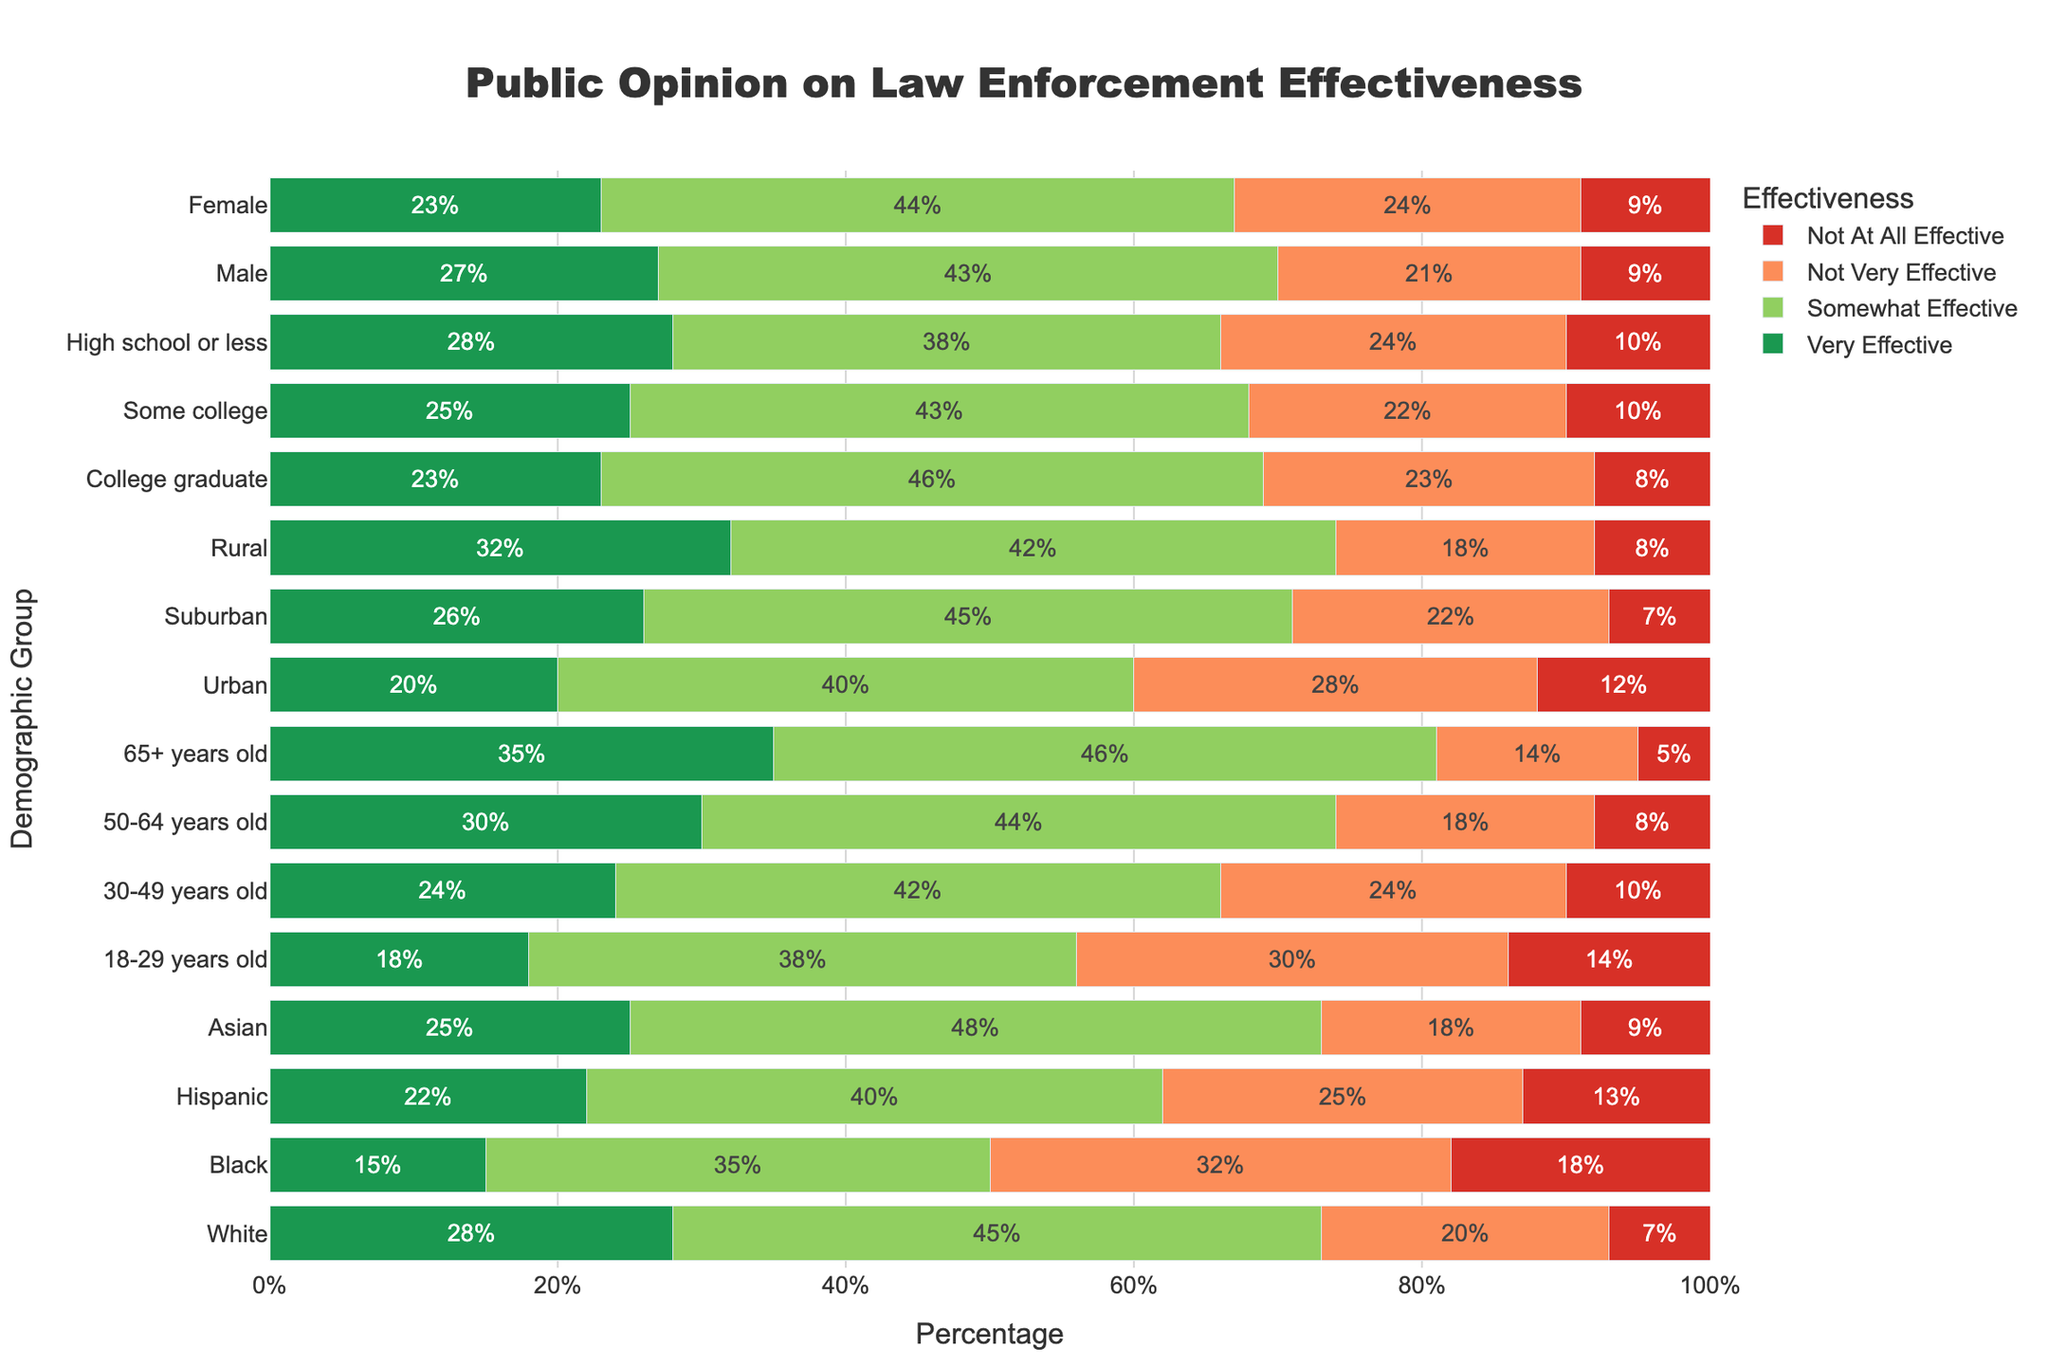What demographic group believes law enforcement is "Very Effective" the most? Looking at the figure, the bar for "Very Effective" is longest for the group "65+ years old" indicating the highest percentage, which is 35%.
Answer: 65+ years old Which group has the highest percentage of people thinking law enforcement is "Not At All Effective"? The longest red bar (representing "Not At All Effective") is for the "Black" demographic, showing 18%.
Answer: Black How does the opinion of "Very Effective" on law enforcement differ between "Male" and "Female"? The "Very Effective" bar for "Male" is at 27%, whereas for "Female" it is at 23%. So the difference is 27% - 23% = 4%.
Answer: 4% Which age group has the greatest percentage of individuals who believe law enforcement is "Not Very Effective"? The longest orange bar (representing "Not Very Effective") among age groups is for "18-29 years old," showing 30%.
Answer: 18-29 years old Compare the percentage of people in "Urban" areas who believe law enforcement is "Somewhat Effective" to those in "Rural" areas. The green bar for "Somewhat Effective" is 40% for "Urban" and 42% for "Rural". Hence, 42% is higher than 40%.
Answer: Rural > Urban What is the combined percentage of "Very Effective" and "Somewhat Effective" for the White demographic? For the White demographic, "Very Effective" is 28% and "Somewhat Effective" is 45%. Combining them leads to 28% + 45% = 73%.
Answer: 73% Which demographic group has the smallest proportion of individuals who think law enforcement is "Not Very Effective"? The shortest orange bar (representing "Not Very Effective") is shown by the "Asian" demographic, at 18%.
Answer: Asian If you add up the percentages of "Not At All Effective" for Black and Hispanic demographics, what do you get? For the Black demographic, "Not At All Effective" is 18%, and for the Hispanic demographic, it’s 13%. Adding them: 18% + 13% = 31%.
Answer: 31% Which education level reported the highest "Very Effective" rating? The longest green bar (representing "Very Effective") among education levels belongs to "High school or less," showing 28%.
Answer: High school or less What percentage of suburban residents think law enforcement is either "Not Very Effective" or "Not At All Effective"? For suburban residents, the percentage for "Not Very Effective" is 22% and for "Not At All Effective" it is 7%. Adding them: 22% + 7% = 29%.
Answer: 29% 